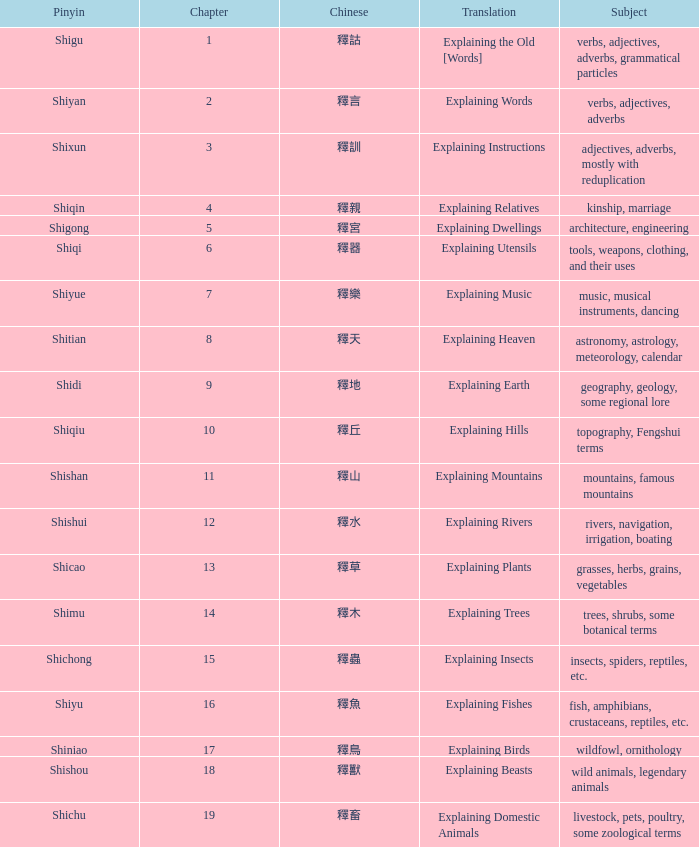Name the chapter with chinese of 釋水 12.0. I'm looking to parse the entire table for insights. Could you assist me with that? {'header': ['Pinyin', 'Chapter', 'Chinese', 'Translation', 'Subject'], 'rows': [['Shigu', '1', '釋詁', 'Explaining the Old [Words]', 'verbs, adjectives, adverbs, grammatical particles'], ['Shiyan', '2', '釋言', 'Explaining Words', 'verbs, adjectives, adverbs'], ['Shixun', '3', '釋訓', 'Explaining Instructions', 'adjectives, adverbs, mostly with reduplication'], ['Shiqin', '4', '釋親', 'Explaining Relatives', 'kinship, marriage'], ['Shigong', '5', '釋宮', 'Explaining Dwellings', 'architecture, engineering'], ['Shiqi', '6', '釋器', 'Explaining Utensils', 'tools, weapons, clothing, and their uses'], ['Shiyue', '7', '釋樂', 'Explaining Music', 'music, musical instruments, dancing'], ['Shitian', '8', '釋天', 'Explaining Heaven', 'astronomy, astrology, meteorology, calendar'], ['Shidi', '9', '釋地', 'Explaining Earth', 'geography, geology, some regional lore'], ['Shiqiu', '10', '釋丘', 'Explaining Hills', 'topography, Fengshui terms'], ['Shishan', '11', '釋山', 'Explaining Mountains', 'mountains, famous mountains'], ['Shishui', '12', '釋水', 'Explaining Rivers', 'rivers, navigation, irrigation, boating'], ['Shicao', '13', '釋草', 'Explaining Plants', 'grasses, herbs, grains, vegetables'], ['Shimu', '14', '釋木', 'Explaining Trees', 'trees, shrubs, some botanical terms'], ['Shichong', '15', '釋蟲', 'Explaining Insects', 'insects, spiders, reptiles, etc.'], ['Shiyu', '16', '釋魚', 'Explaining Fishes', 'fish, amphibians, crustaceans, reptiles, etc.'], ['Shiniao', '17', '釋鳥', 'Explaining Birds', 'wildfowl, ornithology'], ['Shishou', '18', '釋獸', 'Explaining Beasts', 'wild animals, legendary animals'], ['Shichu', '19', '釋畜', 'Explaining Domestic Animals', 'livestock, pets, poultry, some zoological terms']]} 